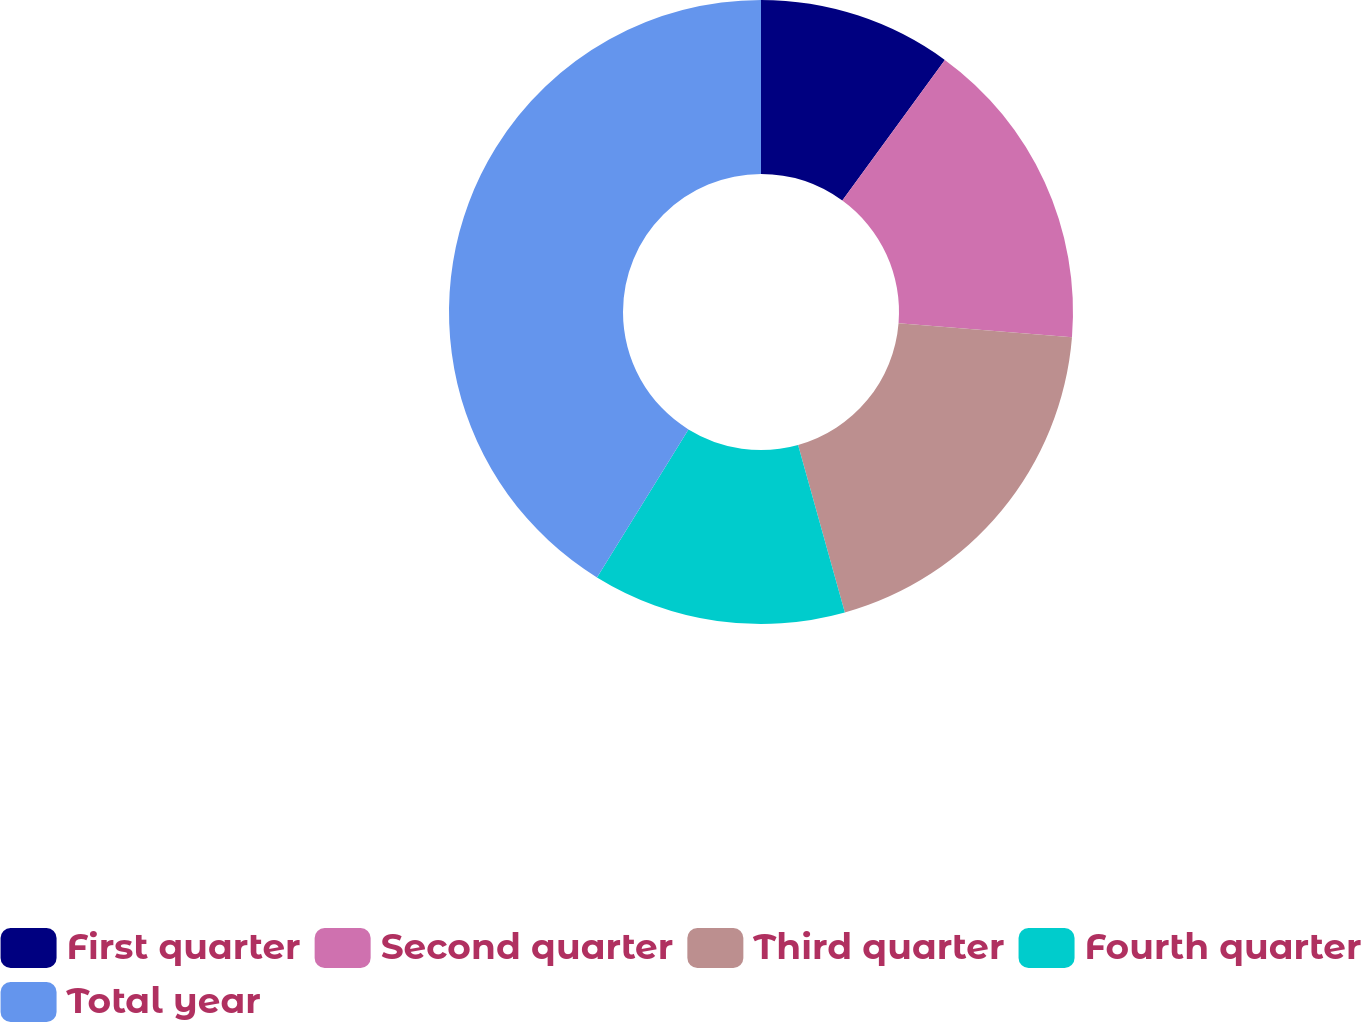<chart> <loc_0><loc_0><loc_500><loc_500><pie_chart><fcel>First quarter<fcel>Second quarter<fcel>Third quarter<fcel>Fourth quarter<fcel>Total year<nl><fcel>10.03%<fcel>16.26%<fcel>19.38%<fcel>13.14%<fcel>41.19%<nl></chart> 